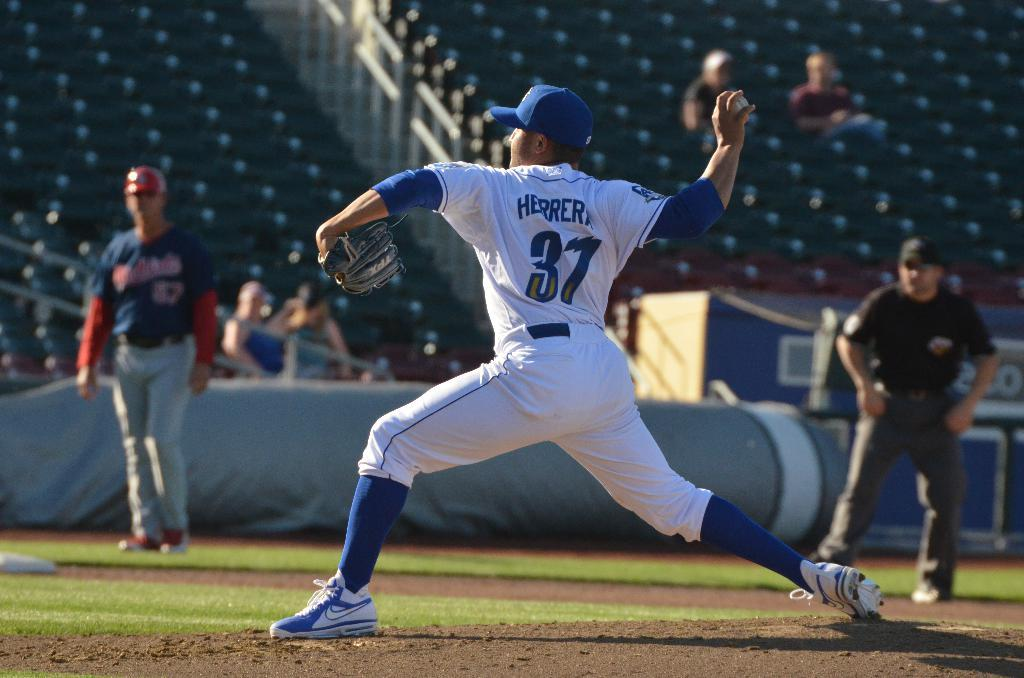<image>
Summarize the visual content of the image. A person throwing a ball, the number 37 is visible on his shirt. 